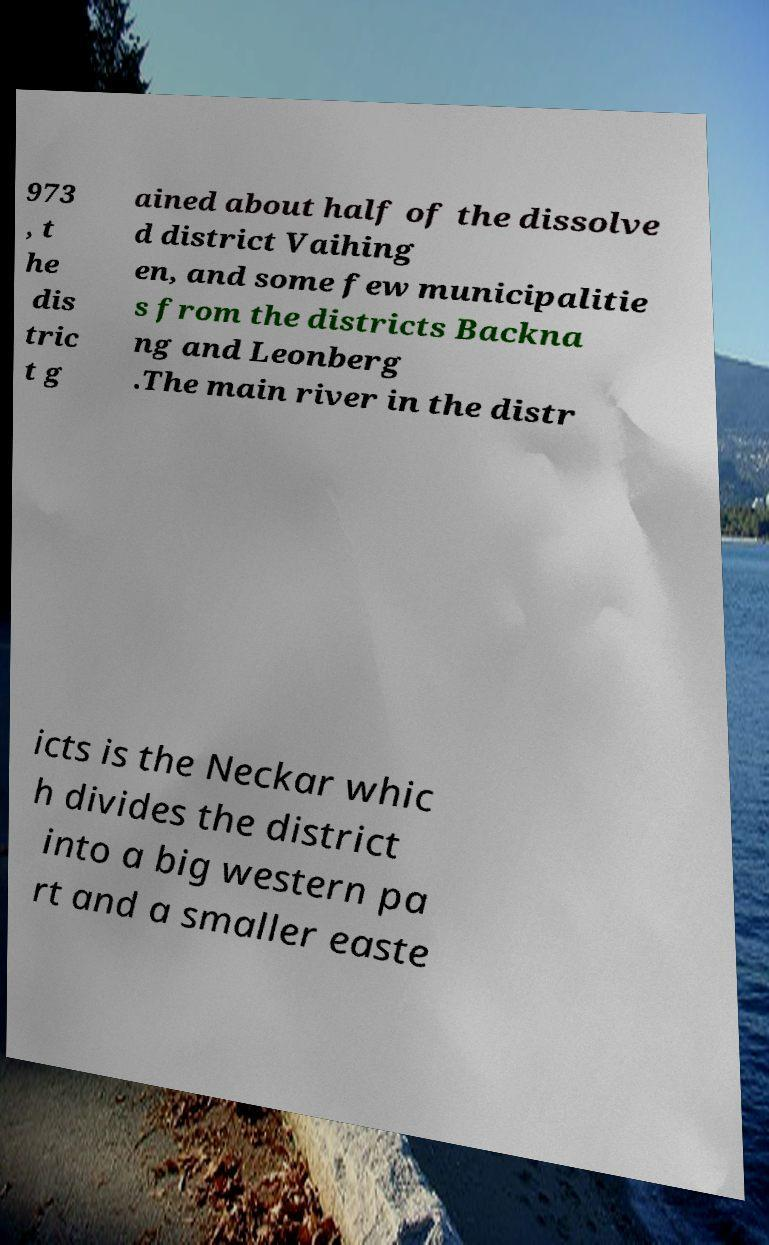Could you assist in decoding the text presented in this image and type it out clearly? 973 , t he dis tric t g ained about half of the dissolve d district Vaihing en, and some few municipalitie s from the districts Backna ng and Leonberg .The main river in the distr icts is the Neckar whic h divides the district into a big western pa rt and a smaller easte 